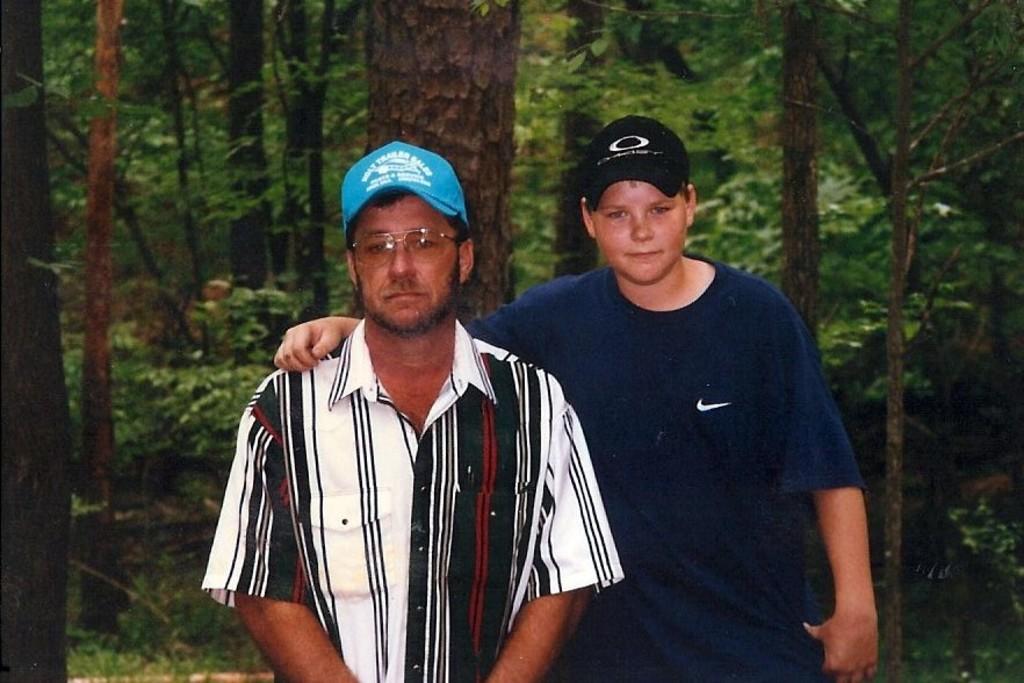Describe this image in one or two sentences. In this picture there is a man who is wearing cap, spectacle and shirt. Beside him there is another man who is wearing cap, t-shirt,trouser and he is smiling. In the background I can see many trees, plants and grass. 